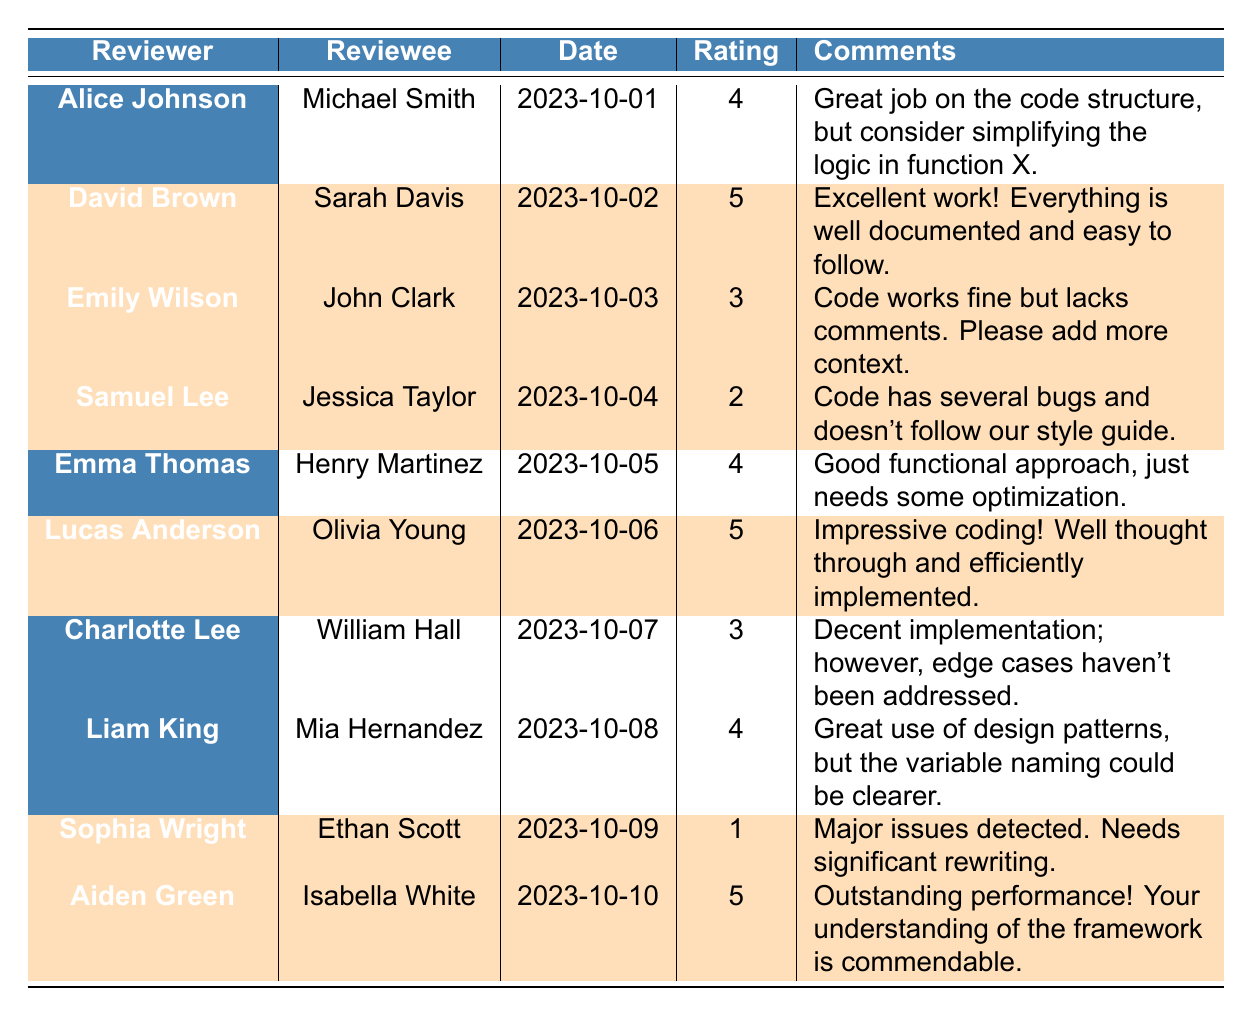What is the highest rating given in the feedback? The maximum rating in the table is 5, provided by David Brown for Sarah Davis, Lucas Anderson for Olivia Young, and Aiden Green for Isabella White.
Answer: 5 How many feedback entries received a rating of 4? There are three entries with a rating of 4: Alice Johnson to Michael Smith, Emma Thomas to Henry Martinez, and Liam King to Mia Hernandez.
Answer: 3 Who gave the lowest rating and what was it? Sophia Wright gave the lowest rating of 1 to Ethan Scott.
Answer: 1 What is the average rating of the feedback? The ratings are 4, 5, 3, 2, 4, 5, 3, 4, 1, and 5. The sum is 36, and there are 10 ratings, so the average is 36/10 = 3.6.
Answer: 3.6 How many review comments were highlighted? The table shows that 5 feedback entries are highlighted, indicating significant points were made in those reviews.
Answer: 5 Did any feedback comments indicate a need for significant rewriting? Yes, Sophia Wright's feedback stated, "Major issues detected. Needs significant rewriting." indicating this concern explicitly.
Answer: Yes Which reviewee received the highest rating and what was that rating? Aiden Green reviewed Isabella White with the highest rating of 5.
Answer: 5 What was the main issue highlighted by Samuel Lee for Jessica Taylor? Samuel Lee noted that the code has several bugs and doesn't follow the style guide, which is a significant concern.
Answer: Several bugs, style guide issues How many feedback entries had positive comments (rating of 4 or 5)? The entries with ratings of 4 or 5 are from David Brown, Lucas Anderson, Aiden Green, Alice Johnson, Emma Thomas, and Liam King, totaling six positive comments.
Answer: 6 Was there any reviewer who gave feedback on multiple reviewees? No reviewer in the data provided commented on multiple reviewees—they each reviewed only one individual.
Answer: No 